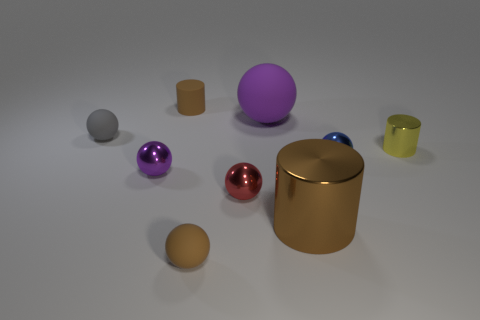Subtract all metallic cylinders. How many cylinders are left? 1 Subtract all gray spheres. How many brown cylinders are left? 2 Subtract 1 cylinders. How many cylinders are left? 2 Add 1 small purple metal things. How many objects exist? 10 Subtract all red balls. How many balls are left? 5 Subtract all cylinders. How many objects are left? 6 Add 2 rubber balls. How many rubber balls are left? 5 Add 4 tiny yellow shiny cylinders. How many tiny yellow shiny cylinders exist? 5 Subtract 1 red spheres. How many objects are left? 8 Subtract all cyan cylinders. Subtract all red cubes. How many cylinders are left? 3 